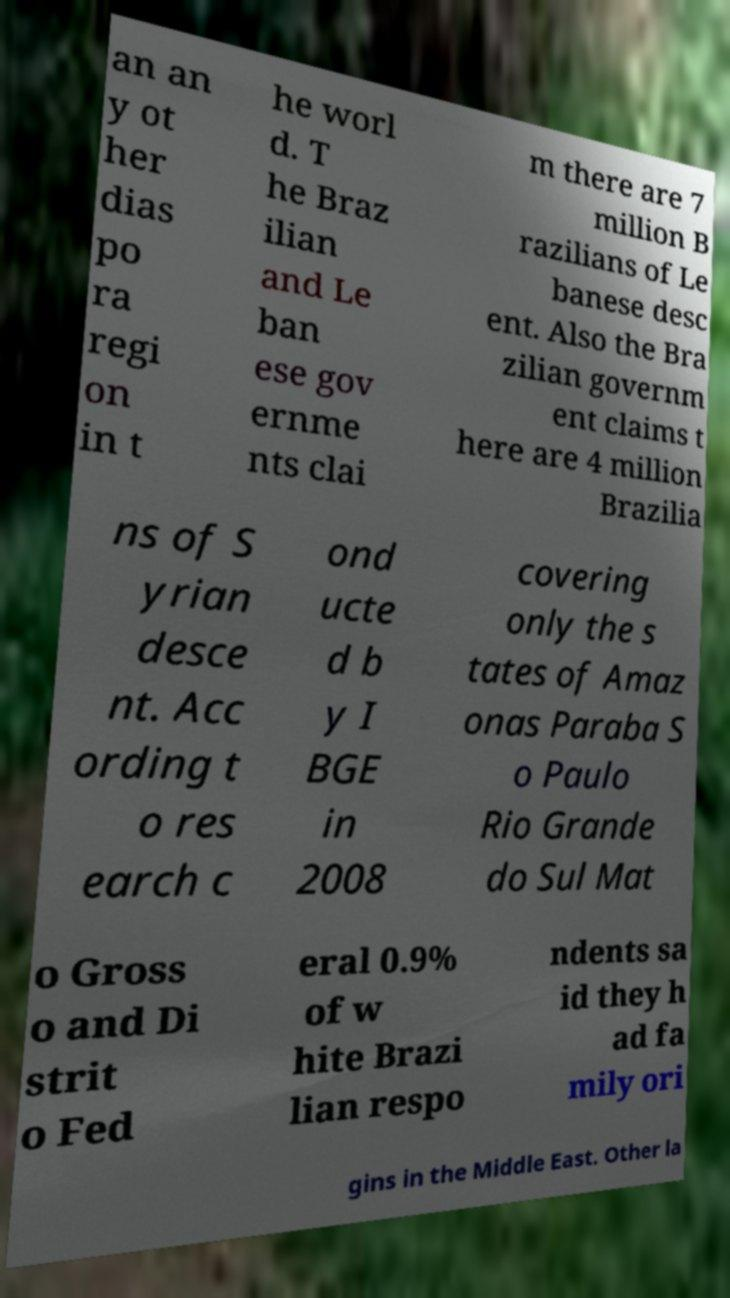There's text embedded in this image that I need extracted. Can you transcribe it verbatim? an an y ot her dias po ra regi on in t he worl d. T he Braz ilian and Le ban ese gov ernme nts clai m there are 7 million B razilians of Le banese desc ent. Also the Bra zilian governm ent claims t here are 4 million Brazilia ns of S yrian desce nt. Acc ording t o res earch c ond ucte d b y I BGE in 2008 covering only the s tates of Amaz onas Paraba S o Paulo Rio Grande do Sul Mat o Gross o and Di strit o Fed eral 0.9% of w hite Brazi lian respo ndents sa id they h ad fa mily ori gins in the Middle East. Other la 